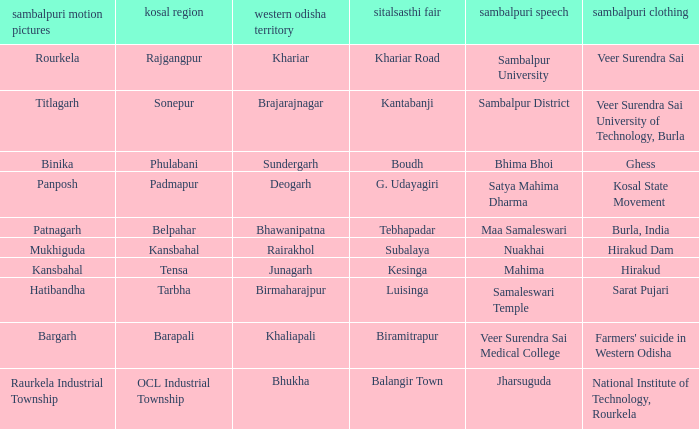What is the Kosal with a balangir town sitalsasthi carnival? OCL Industrial Township. 